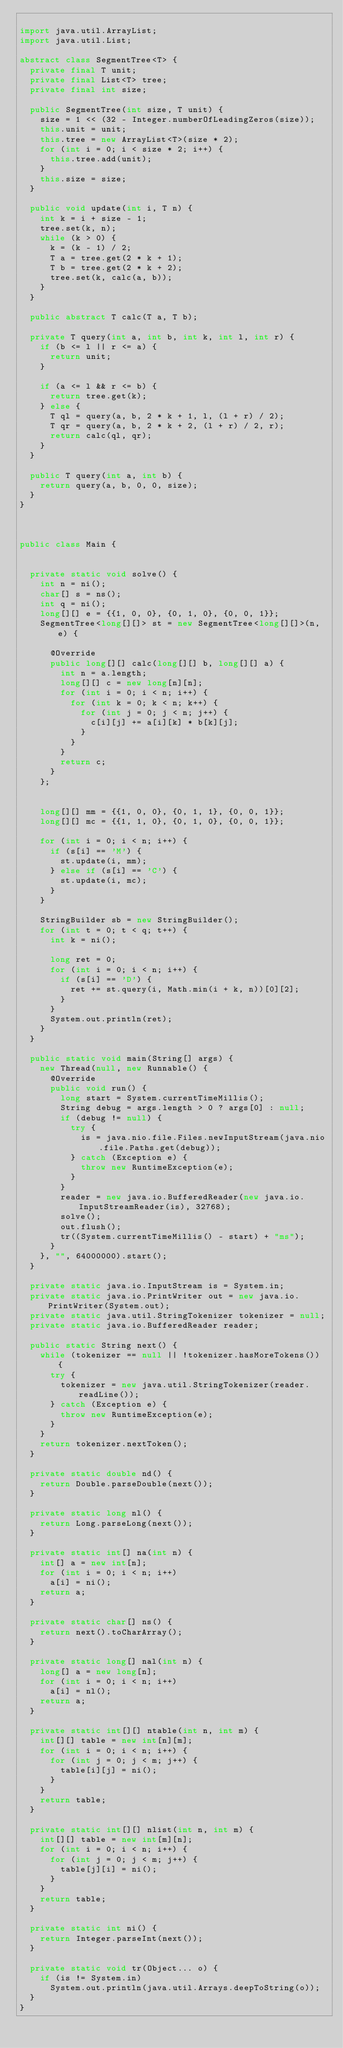<code> <loc_0><loc_0><loc_500><loc_500><_Java_>
import java.util.ArrayList;
import java.util.List;

abstract class SegmentTree<T> {
  private final T unit;
  private final List<T> tree;
  private final int size;

  public SegmentTree(int size, T unit) {
    size = 1 << (32 - Integer.numberOfLeadingZeros(size));
    this.unit = unit;
    this.tree = new ArrayList<T>(size * 2);
    for (int i = 0; i < size * 2; i++) {
      this.tree.add(unit);
    }
    this.size = size;
  }

  public void update(int i, T n) {
    int k = i + size - 1;
    tree.set(k, n);
    while (k > 0) {
      k = (k - 1) / 2;
      T a = tree.get(2 * k + 1);
      T b = tree.get(2 * k + 2);
      tree.set(k, calc(a, b));
    }
  }

  public abstract T calc(T a, T b);

  private T query(int a, int b, int k, int l, int r) {
    if (b <= l || r <= a) {
      return unit;
    }

    if (a <= l && r <= b) {
      return tree.get(k);
    } else {
      T ql = query(a, b, 2 * k + 1, l, (l + r) / 2);
      T qr = query(a, b, 2 * k + 2, (l + r) / 2, r);
      return calc(ql, qr);
    }
  }

  public T query(int a, int b) {
    return query(a, b, 0, 0, size);
  }
}



public class Main {


  private static void solve() {
    int n = ni();
    char[] s = ns();
    int q = ni();
    long[][] e = {{1, 0, 0}, {0, 1, 0}, {0, 0, 1}};
    SegmentTree<long[][]> st = new SegmentTree<long[][]>(n, e) {

      @Override
      public long[][] calc(long[][] b, long[][] a) {
        int n = a.length;
        long[][] c = new long[n][n];
        for (int i = 0; i < n; i++) {
          for (int k = 0; k < n; k++) {
            for (int j = 0; j < n; j++) {
              c[i][j] += a[i][k] * b[k][j];
            }
          }
        }
        return c;
      }
    };


    long[][] mm = {{1, 0, 0}, {0, 1, 1}, {0, 0, 1}};
    long[][] mc = {{1, 1, 0}, {0, 1, 0}, {0, 0, 1}};

    for (int i = 0; i < n; i++) {
      if (s[i] == 'M') {
        st.update(i, mm);
      } else if (s[i] == 'C') {
        st.update(i, mc);
      }
    }

    StringBuilder sb = new StringBuilder();
    for (int t = 0; t < q; t++) {
      int k = ni();

      long ret = 0;
      for (int i = 0; i < n; i++) {
        if (s[i] == 'D') {
          ret += st.query(i, Math.min(i + k, n))[0][2];
        }
      }
      System.out.println(ret);
    }
  }

  public static void main(String[] args) {
    new Thread(null, new Runnable() {
      @Override
      public void run() {
        long start = System.currentTimeMillis();
        String debug = args.length > 0 ? args[0] : null;
        if (debug != null) {
          try {
            is = java.nio.file.Files.newInputStream(java.nio.file.Paths.get(debug));
          } catch (Exception e) {
            throw new RuntimeException(e);
          }
        }
        reader = new java.io.BufferedReader(new java.io.InputStreamReader(is), 32768);
        solve();
        out.flush();
        tr((System.currentTimeMillis() - start) + "ms");
      }
    }, "", 64000000).start();
  }

  private static java.io.InputStream is = System.in;
  private static java.io.PrintWriter out = new java.io.PrintWriter(System.out);
  private static java.util.StringTokenizer tokenizer = null;
  private static java.io.BufferedReader reader;

  public static String next() {
    while (tokenizer == null || !tokenizer.hasMoreTokens()) {
      try {
        tokenizer = new java.util.StringTokenizer(reader.readLine());
      } catch (Exception e) {
        throw new RuntimeException(e);
      }
    }
    return tokenizer.nextToken();
  }

  private static double nd() {
    return Double.parseDouble(next());
  }

  private static long nl() {
    return Long.parseLong(next());
  }

  private static int[] na(int n) {
    int[] a = new int[n];
    for (int i = 0; i < n; i++)
      a[i] = ni();
    return a;
  }

  private static char[] ns() {
    return next().toCharArray();
  }

  private static long[] nal(int n) {
    long[] a = new long[n];
    for (int i = 0; i < n; i++)
      a[i] = nl();
    return a;
  }

  private static int[][] ntable(int n, int m) {
    int[][] table = new int[n][m];
    for (int i = 0; i < n; i++) {
      for (int j = 0; j < m; j++) {
        table[i][j] = ni();
      }
    }
    return table;
  }

  private static int[][] nlist(int n, int m) {
    int[][] table = new int[m][n];
    for (int i = 0; i < n; i++) {
      for (int j = 0; j < m; j++) {
        table[j][i] = ni();
      }
    }
    return table;
  }

  private static int ni() {
    return Integer.parseInt(next());
  }

  private static void tr(Object... o) {
    if (is != System.in)
      System.out.println(java.util.Arrays.deepToString(o));
  }
}

</code> 